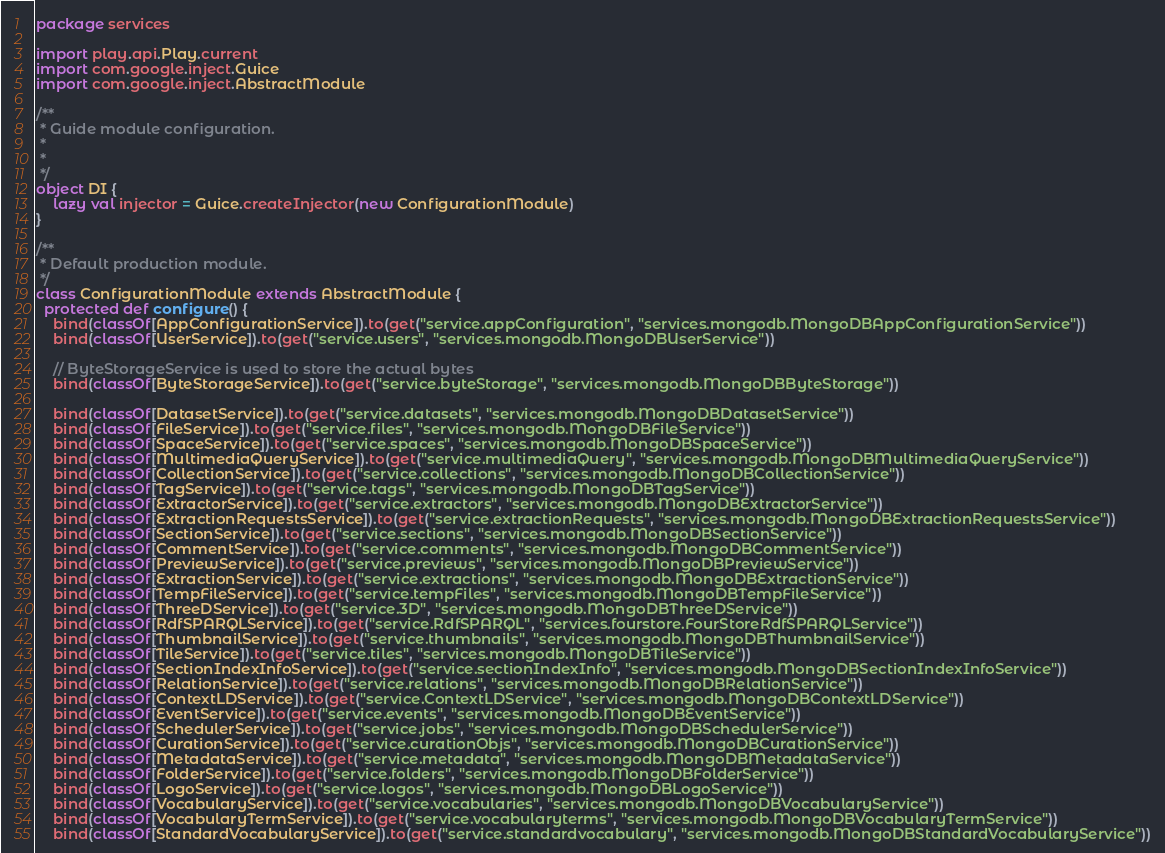<code> <loc_0><loc_0><loc_500><loc_500><_Scala_>package services

import play.api.Play.current
import com.google.inject.Guice
import com.google.inject.AbstractModule

/**
 * Guide module configuration.
 *
 *
 */
object DI {
    lazy val injector = Guice.createInjector(new ConfigurationModule)
}

/**
 * Default production module.
 */
class ConfigurationModule extends AbstractModule {
  protected def configure() {
    bind(classOf[AppConfigurationService]).to(get("service.appConfiguration", "services.mongodb.MongoDBAppConfigurationService"))
    bind(classOf[UserService]).to(get("service.users", "services.mongodb.MongoDBUserService"))

    // ByteStorageService is used to store the actual bytes
    bind(classOf[ByteStorageService]).to(get("service.byteStorage", "services.mongodb.MongoDBByteStorage"))

    bind(classOf[DatasetService]).to(get("service.datasets", "services.mongodb.MongoDBDatasetService"))
    bind(classOf[FileService]).to(get("service.files", "services.mongodb.MongoDBFileService"))
    bind(classOf[SpaceService]).to(get("service.spaces", "services.mongodb.MongoDBSpaceService"))
    bind(classOf[MultimediaQueryService]).to(get("service.multimediaQuery", "services.mongodb.MongoDBMultimediaQueryService"))
    bind(classOf[CollectionService]).to(get("service.collections", "services.mongodb.MongoDBCollectionService"))
    bind(classOf[TagService]).to(get("service.tags", "services.mongodb.MongoDBTagService"))
    bind(classOf[ExtractorService]).to(get("service.extractors", "services.mongodb.MongoDBExtractorService"))
    bind(classOf[ExtractionRequestsService]).to(get("service.extractionRequests", "services.mongodb.MongoDBExtractionRequestsService"))
    bind(classOf[SectionService]).to(get("service.sections", "services.mongodb.MongoDBSectionService"))
    bind(classOf[CommentService]).to(get("service.comments", "services.mongodb.MongoDBCommentService"))
    bind(classOf[PreviewService]).to(get("service.previews", "services.mongodb.MongoDBPreviewService"))
    bind(classOf[ExtractionService]).to(get("service.extractions", "services.mongodb.MongoDBExtractionService"))
    bind(classOf[TempFileService]).to(get("service.tempFiles", "services.mongodb.MongoDBTempFileService"))
    bind(classOf[ThreeDService]).to(get("service.3D", "services.mongodb.MongoDBThreeDService"))
    bind(classOf[RdfSPARQLService]).to(get("service.RdfSPARQL", "services.fourstore.FourStoreRdfSPARQLService"))
    bind(classOf[ThumbnailService]).to(get("service.thumbnails", "services.mongodb.MongoDBThumbnailService"))
    bind(classOf[TileService]).to(get("service.tiles", "services.mongodb.MongoDBTileService"))
    bind(classOf[SectionIndexInfoService]).to(get("service.sectionIndexInfo", "services.mongodb.MongoDBSectionIndexInfoService"))
    bind(classOf[RelationService]).to(get("service.relations", "services.mongodb.MongoDBRelationService"))
    bind(classOf[ContextLDService]).to(get("service.ContextLDService", "services.mongodb.MongoDBContextLDService"))
    bind(classOf[EventService]).to(get("service.events", "services.mongodb.MongoDBEventService"))
    bind(classOf[SchedulerService]).to(get("service.jobs", "services.mongodb.MongoDBSchedulerService"))
    bind(classOf[CurationService]).to(get("service.curationObjs", "services.mongodb.MongoDBCurationService"))
    bind(classOf[MetadataService]).to(get("service.metadata", "services.mongodb.MongoDBMetadataService"))
    bind(classOf[FolderService]).to(get("service.folders", "services.mongodb.MongoDBFolderService"))
    bind(classOf[LogoService]).to(get("service.logos", "services.mongodb.MongoDBLogoService"))
    bind(classOf[VocabularyService]).to(get("service.vocabularies", "services.mongodb.MongoDBVocabularyService"))
    bind(classOf[VocabularyTermService]).to(get("service.vocabularyterms", "services.mongodb.MongoDBVocabularyTermService"))
    bind(classOf[StandardVocabularyService]).to(get("service.standardvocabulary", "services.mongodb.MongoDBStandardVocabularyService"))</code> 